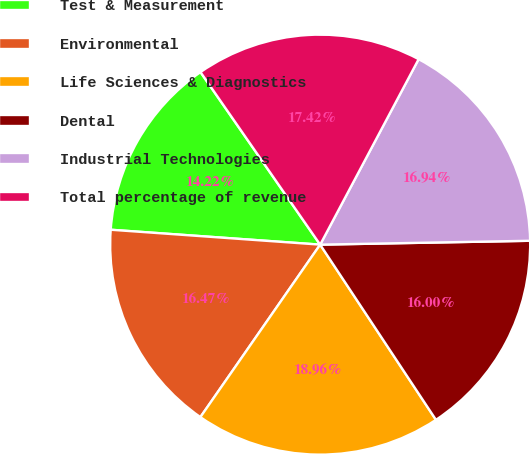Convert chart to OTSL. <chart><loc_0><loc_0><loc_500><loc_500><pie_chart><fcel>Test & Measurement<fcel>Environmental<fcel>Life Sciences & Diagnostics<fcel>Dental<fcel>Industrial Technologies<fcel>Total percentage of revenue<nl><fcel>14.22%<fcel>16.47%<fcel>18.96%<fcel>16.0%<fcel>16.94%<fcel>17.42%<nl></chart> 